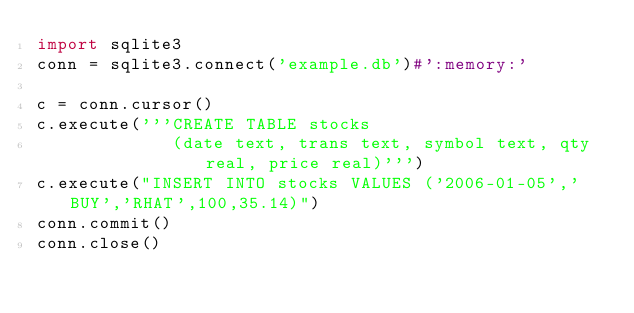<code> <loc_0><loc_0><loc_500><loc_500><_Python_>import sqlite3
conn = sqlite3.connect('example.db')#':memory:'

c = conn.cursor()
c.execute('''CREATE TABLE stocks
             (date text, trans text, symbol text, qty real, price real)''')
c.execute("INSERT INTO stocks VALUES ('2006-01-05','BUY','RHAT',100,35.14)")
conn.commit()
conn.close()

</code> 